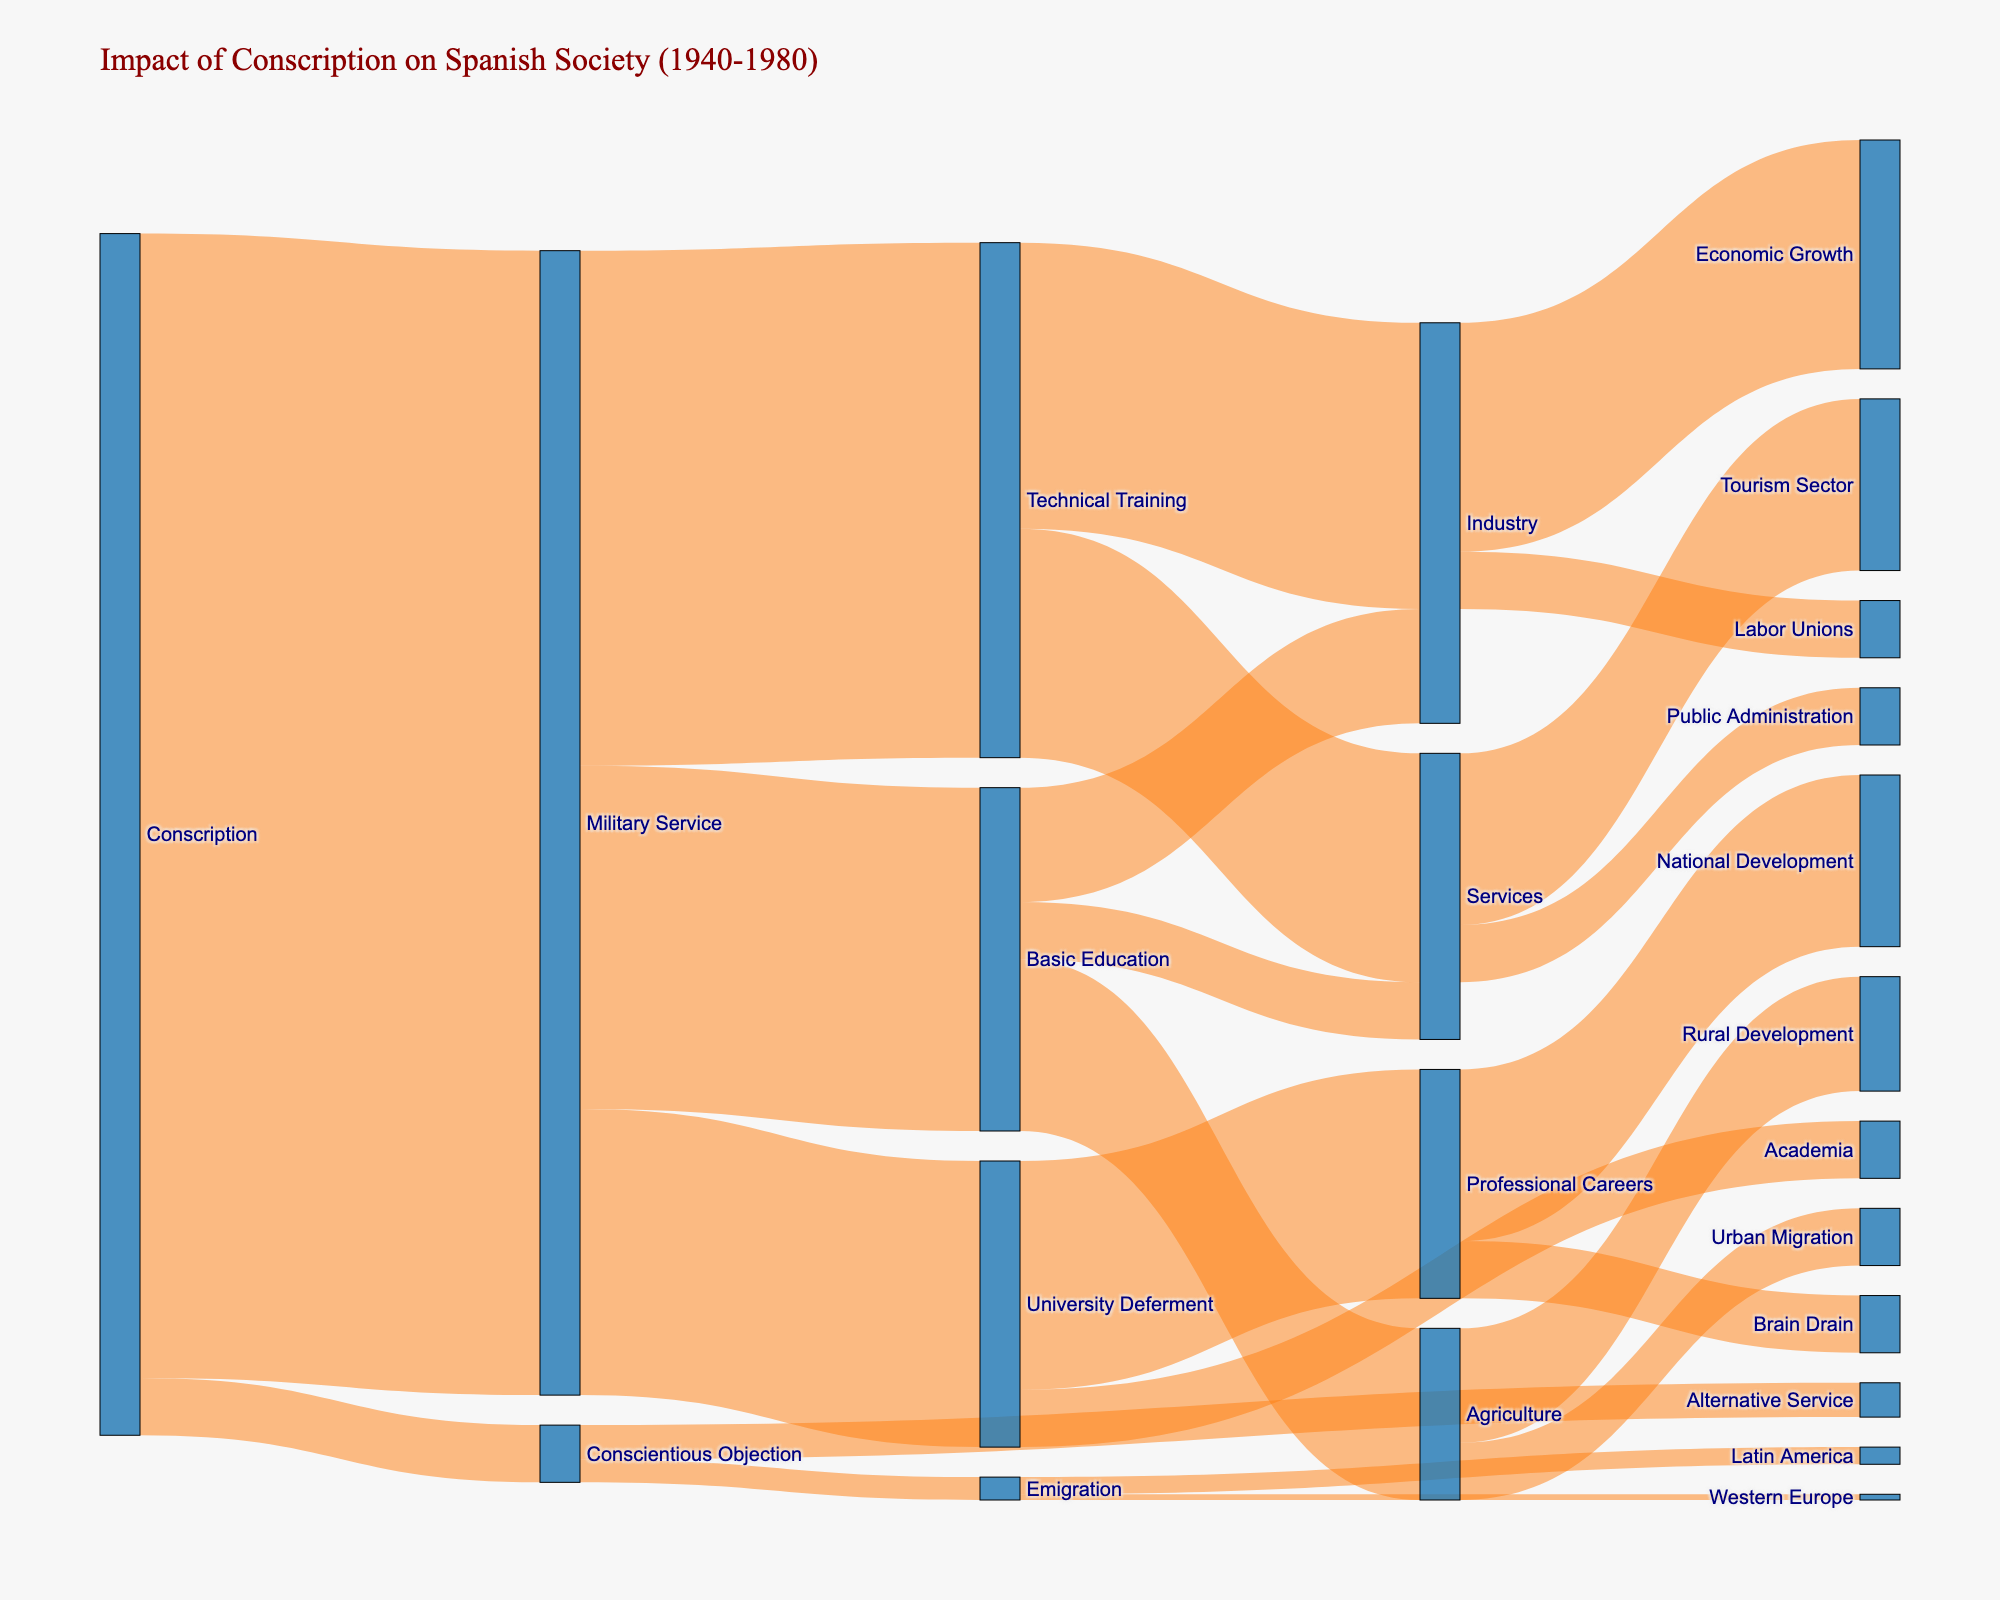What is the main title of the Sankey diagram? The title is prominently displayed at the top of the diagram. It reads "Impact of Conscription on Spanish Society (1940-1980)".
Answer: Impact of Conscription on Spanish Society (1940-1980) What is the largest flow from 'Conscription'? By looking at the flow thickness, the largest flow from 'Conscription' goes towards 'Military Service'. This flow has a value of 1,000,000.
Answer: Military Service How many individuals went into Technical Training from Military Service? The thickness of the flow from 'Military Service' to 'Technical Training' indicates that 450,000 individuals went into Technical Training.
Answer: 450,000 Which category has the least flow from Basic Education? By comparing the flow thicknesses from 'Basic Education', the smallest flow is towards 'Services', with a value of 50,000.
Answer: Services How many individuals in total went into Services from Basic Education and Technical Training combined? Adding the values from 'Basic Education' to 'Services' (50,000) and 'Technical Training' to 'Services' (200,000), we get a total of 250,000 individuals.
Answer: 250,000 Which had a higher number of individuals, 'Professional Careers' or 'Academia'? Comparing the flow thicknesses from 'University Deferment', 'Professional Careers' had a higher number of individuals (200,000) than 'Academia' (50,000).
Answer: Professional Careers How many individuals opted for Conscientious Objection? The thickness of the flow from 'Conscription' to 'Conscientious Objection' is 50,000.
Answer: 50,000 What is the total value of individuals who pursued education related outcomes (Basic Education, Technical Training, and University Deferment) from Military Service? Adding the values: 'Basic Education' (300,000), 'Technical Training' (450,000), and 'University Deferment' (250,000). The total is 1,000,000.
Answer: 1,000,000 Did more people go into Urban Migration or remain in Rural Development from Agriculture? By comparing flow thicknesses from 'Agriculture', 100,000 remained in 'Rural Development' while 50,000 moved to 'Urban Migration'. More remained in Rural Development.
Answer: Rural Development What are the two emigration destinations and their respective values? The flows from 'Emigration' show two destinations: 'Latin America' with 15,000 and 'Western Europe' with 5,000.
Answer: Latin America (15,000) and Western Europe (5,000) 